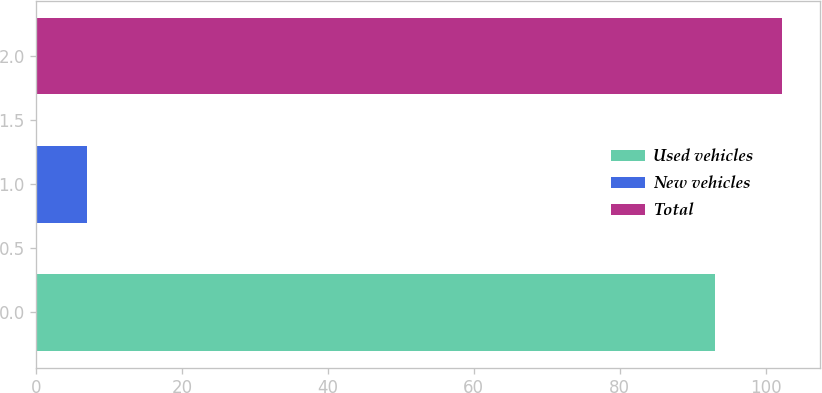<chart> <loc_0><loc_0><loc_500><loc_500><bar_chart><fcel>Used vehicles<fcel>New vehicles<fcel>Total<nl><fcel>93<fcel>7<fcel>102.3<nl></chart> 